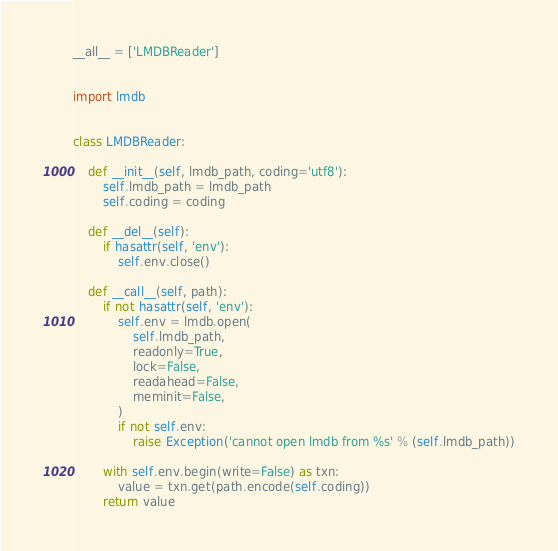<code> <loc_0><loc_0><loc_500><loc_500><_Python_>__all__ = ['LMDBReader']


import lmdb


class LMDBReader:

    def __init__(self, lmdb_path, coding='utf8'):
        self.lmdb_path = lmdb_path
        self.coding = coding

    def __del__(self):
        if hasattr(self, 'env'):
            self.env.close()

    def __call__(self, path):
        if not hasattr(self, 'env'):
            self.env = lmdb.open(
                self.lmdb_path,
                readonly=True,
                lock=False,
                readahead=False,
                meminit=False,
            )
            if not self.env:
                raise Exception('cannot open lmdb from %s' % (self.lmdb_path))

        with self.env.begin(write=False) as txn:
            value = txn.get(path.encode(self.coding))
        return value
</code> 